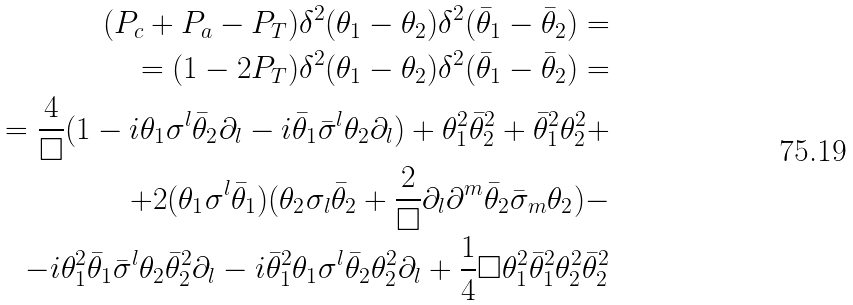Convert formula to latex. <formula><loc_0><loc_0><loc_500><loc_500>( P _ { c } + P _ { a } - P _ { T } ) \delta ^ { 2 } ( \theta _ { 1 } - \theta _ { 2 } ) \delta ^ { 2 } ( \bar { \theta } _ { 1 } - \bar { \theta } _ { 2 } ) = \\ = ( 1 - 2 P _ { T } ) \delta ^ { 2 } ( \theta _ { 1 } - \theta _ { 2 } ) \delta ^ { 2 } ( \bar { \theta } _ { 1 } - \bar { \theta } _ { 2 } ) = \\ = \frac { 4 } { \square } ( 1 - i \theta _ { 1 } \sigma ^ { l } \bar { \theta } _ { 2 } \partial _ { l } - i \bar { \theta } _ { 1 } \bar { \sigma } ^ { l } \theta _ { 2 } \partial _ { l } ) + \theta _ { 1 } ^ { 2 } \bar { \theta } _ { 2 } ^ { 2 } + \bar { \theta } _ { 1 } ^ { 2 } \theta _ { 2 } ^ { 2 } + \\ + 2 ( \theta _ { 1 } \sigma ^ { l } \bar { \theta } _ { 1 } ) ( \theta _ { 2 } \sigma _ { l } \bar { \theta } _ { 2 } + \frac { 2 } { \square } \partial _ { l } \partial ^ { m } \bar { \theta } _ { 2 } \bar { \sigma } _ { m } \theta _ { 2 } ) - \\ - i \theta _ { 1 } ^ { 2 } \bar { \theta } _ { 1 } \bar { \sigma } ^ { l } \theta _ { 2 } \bar { \theta } _ { 2 } ^ { 2 } \partial _ { l } - i \bar { \theta } _ { 1 } ^ { 2 } \theta _ { 1 } \sigma ^ { l } \bar { \theta } _ { 2 } \theta _ { 2 } ^ { 2 } \partial _ { l } + \frac { 1 } { 4 } \square \theta _ { 1 } ^ { 2 } \bar { \theta } _ { 1 } ^ { 2 } \theta _ { 2 } ^ { 2 } \bar { \theta } _ { 2 } ^ { 2 }</formula> 